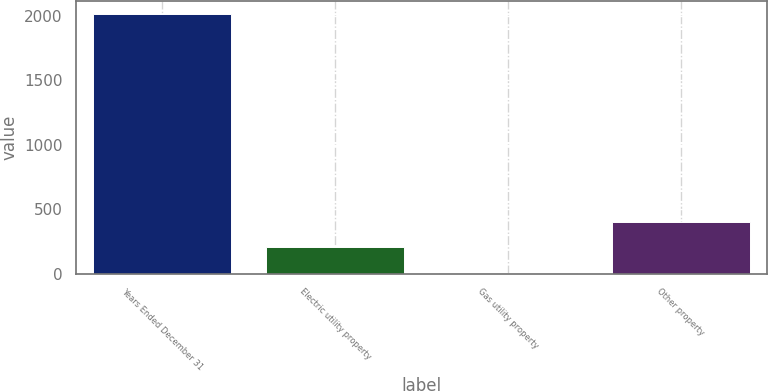Convert chart. <chart><loc_0><loc_0><loc_500><loc_500><bar_chart><fcel>Years Ended December 31<fcel>Electric utility property<fcel>Gas utility property<fcel>Other property<nl><fcel>2013<fcel>203.82<fcel>2.8<fcel>404.84<nl></chart> 